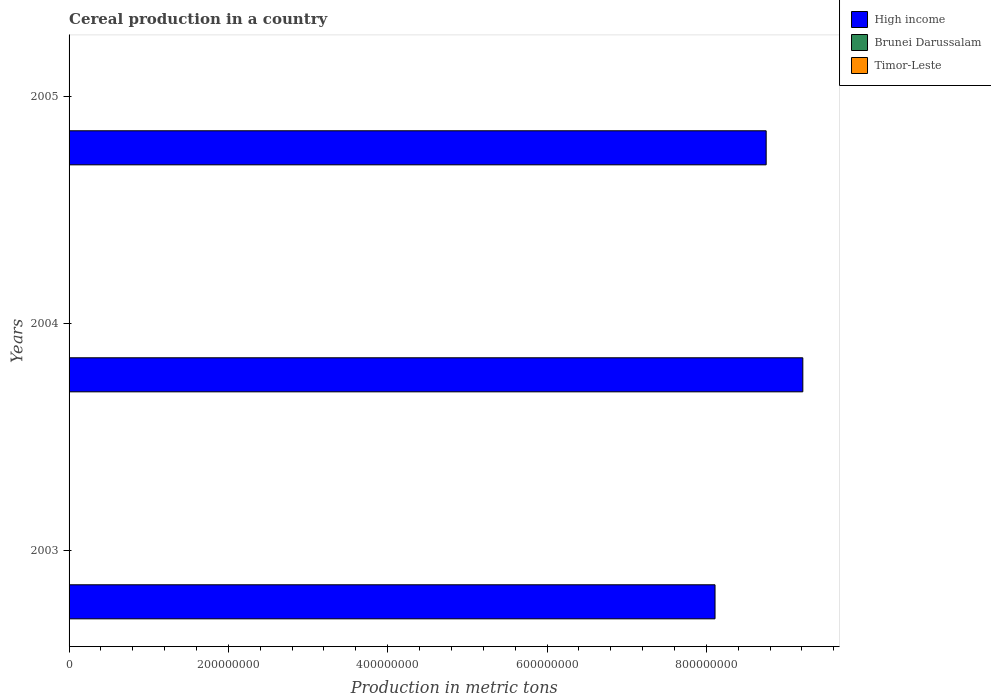How many groups of bars are there?
Ensure brevity in your answer.  3. Are the number of bars per tick equal to the number of legend labels?
Keep it short and to the point. Yes. What is the label of the 3rd group of bars from the top?
Provide a short and direct response. 2003. In how many cases, is the number of bars for a given year not equal to the number of legend labels?
Your answer should be compact. 0. What is the total cereal production in Timor-Leste in 2005?
Your response must be concise. 1.51e+05. Across all years, what is the maximum total cereal production in Brunei Darussalam?
Your response must be concise. 851. Across all years, what is the minimum total cereal production in Brunei Darussalam?
Offer a very short reply. 547. In which year was the total cereal production in Brunei Darussalam minimum?
Your answer should be very brief. 2003. What is the total total cereal production in Brunei Darussalam in the graph?
Make the answer very short. 2018. What is the difference between the total cereal production in Brunei Darussalam in 2003 and that in 2004?
Ensure brevity in your answer.  -73. What is the difference between the total cereal production in Timor-Leste in 2004 and the total cereal production in Brunei Darussalam in 2003?
Give a very brief answer. 1.17e+05. What is the average total cereal production in Brunei Darussalam per year?
Offer a very short reply. 672.67. In the year 2005, what is the difference between the total cereal production in High income and total cereal production in Timor-Leste?
Ensure brevity in your answer.  8.75e+08. In how many years, is the total cereal production in High income greater than 760000000 metric tons?
Your answer should be compact. 3. What is the ratio of the total cereal production in Brunei Darussalam in 2003 to that in 2005?
Provide a succinct answer. 0.64. Is the difference between the total cereal production in High income in 2003 and 2004 greater than the difference between the total cereal production in Timor-Leste in 2003 and 2004?
Offer a very short reply. No. What is the difference between the highest and the second highest total cereal production in High income?
Offer a terse response. 4.60e+07. What is the difference between the highest and the lowest total cereal production in High income?
Offer a terse response. 1.10e+08. In how many years, is the total cereal production in High income greater than the average total cereal production in High income taken over all years?
Provide a succinct answer. 2. What does the 1st bar from the top in 2005 represents?
Keep it short and to the point. Timor-Leste. What does the 2nd bar from the bottom in 2005 represents?
Your response must be concise. Brunei Darussalam. Is it the case that in every year, the sum of the total cereal production in Timor-Leste and total cereal production in High income is greater than the total cereal production in Brunei Darussalam?
Provide a succinct answer. Yes. How many years are there in the graph?
Provide a short and direct response. 3. Are the values on the major ticks of X-axis written in scientific E-notation?
Make the answer very short. No. Does the graph contain any zero values?
Your answer should be very brief. No. Does the graph contain grids?
Make the answer very short. No. How many legend labels are there?
Give a very brief answer. 3. What is the title of the graph?
Your answer should be compact. Cereal production in a country. What is the label or title of the X-axis?
Provide a short and direct response. Production in metric tons. What is the Production in metric tons in High income in 2003?
Offer a terse response. 8.11e+08. What is the Production in metric tons in Brunei Darussalam in 2003?
Provide a short and direct response. 547. What is the Production in metric tons of Timor-Leste in 2003?
Keep it short and to the point. 1.36e+05. What is the Production in metric tons of High income in 2004?
Offer a terse response. 9.21e+08. What is the Production in metric tons in Brunei Darussalam in 2004?
Provide a short and direct response. 620. What is the Production in metric tons in Timor-Leste in 2004?
Provide a succinct answer. 1.17e+05. What is the Production in metric tons of High income in 2005?
Keep it short and to the point. 8.75e+08. What is the Production in metric tons in Brunei Darussalam in 2005?
Make the answer very short. 851. What is the Production in metric tons in Timor-Leste in 2005?
Provide a short and direct response. 1.51e+05. Across all years, what is the maximum Production in metric tons in High income?
Your response must be concise. 9.21e+08. Across all years, what is the maximum Production in metric tons in Brunei Darussalam?
Offer a very short reply. 851. Across all years, what is the maximum Production in metric tons in Timor-Leste?
Provide a short and direct response. 1.51e+05. Across all years, what is the minimum Production in metric tons of High income?
Give a very brief answer. 8.11e+08. Across all years, what is the minimum Production in metric tons in Brunei Darussalam?
Your response must be concise. 547. Across all years, what is the minimum Production in metric tons in Timor-Leste?
Ensure brevity in your answer.  1.17e+05. What is the total Production in metric tons of High income in the graph?
Make the answer very short. 2.61e+09. What is the total Production in metric tons in Brunei Darussalam in the graph?
Offer a very short reply. 2018. What is the total Production in metric tons of Timor-Leste in the graph?
Your response must be concise. 4.04e+05. What is the difference between the Production in metric tons in High income in 2003 and that in 2004?
Keep it short and to the point. -1.10e+08. What is the difference between the Production in metric tons in Brunei Darussalam in 2003 and that in 2004?
Keep it short and to the point. -73. What is the difference between the Production in metric tons in Timor-Leste in 2003 and that in 2004?
Give a very brief answer. 1.84e+04. What is the difference between the Production in metric tons in High income in 2003 and that in 2005?
Your response must be concise. -6.42e+07. What is the difference between the Production in metric tons in Brunei Darussalam in 2003 and that in 2005?
Your answer should be compact. -304. What is the difference between the Production in metric tons in Timor-Leste in 2003 and that in 2005?
Keep it short and to the point. -1.55e+04. What is the difference between the Production in metric tons of High income in 2004 and that in 2005?
Your response must be concise. 4.60e+07. What is the difference between the Production in metric tons in Brunei Darussalam in 2004 and that in 2005?
Provide a succinct answer. -231. What is the difference between the Production in metric tons of Timor-Leste in 2004 and that in 2005?
Your answer should be compact. -3.39e+04. What is the difference between the Production in metric tons of High income in 2003 and the Production in metric tons of Brunei Darussalam in 2004?
Your answer should be very brief. 8.11e+08. What is the difference between the Production in metric tons of High income in 2003 and the Production in metric tons of Timor-Leste in 2004?
Make the answer very short. 8.11e+08. What is the difference between the Production in metric tons in Brunei Darussalam in 2003 and the Production in metric tons in Timor-Leste in 2004?
Your answer should be very brief. -1.17e+05. What is the difference between the Production in metric tons in High income in 2003 and the Production in metric tons in Brunei Darussalam in 2005?
Give a very brief answer. 8.11e+08. What is the difference between the Production in metric tons of High income in 2003 and the Production in metric tons of Timor-Leste in 2005?
Ensure brevity in your answer.  8.11e+08. What is the difference between the Production in metric tons in Brunei Darussalam in 2003 and the Production in metric tons in Timor-Leste in 2005?
Provide a succinct answer. -1.51e+05. What is the difference between the Production in metric tons of High income in 2004 and the Production in metric tons of Brunei Darussalam in 2005?
Your answer should be very brief. 9.21e+08. What is the difference between the Production in metric tons in High income in 2004 and the Production in metric tons in Timor-Leste in 2005?
Offer a terse response. 9.21e+08. What is the difference between the Production in metric tons in Brunei Darussalam in 2004 and the Production in metric tons in Timor-Leste in 2005?
Make the answer very short. -1.50e+05. What is the average Production in metric tons of High income per year?
Provide a succinct answer. 8.69e+08. What is the average Production in metric tons in Brunei Darussalam per year?
Make the answer very short. 672.67. What is the average Production in metric tons in Timor-Leste per year?
Offer a very short reply. 1.35e+05. In the year 2003, what is the difference between the Production in metric tons of High income and Production in metric tons of Brunei Darussalam?
Your answer should be very brief. 8.11e+08. In the year 2003, what is the difference between the Production in metric tons in High income and Production in metric tons in Timor-Leste?
Ensure brevity in your answer.  8.11e+08. In the year 2003, what is the difference between the Production in metric tons of Brunei Darussalam and Production in metric tons of Timor-Leste?
Offer a terse response. -1.35e+05. In the year 2004, what is the difference between the Production in metric tons of High income and Production in metric tons of Brunei Darussalam?
Your answer should be compact. 9.21e+08. In the year 2004, what is the difference between the Production in metric tons of High income and Production in metric tons of Timor-Leste?
Give a very brief answer. 9.21e+08. In the year 2004, what is the difference between the Production in metric tons in Brunei Darussalam and Production in metric tons in Timor-Leste?
Ensure brevity in your answer.  -1.17e+05. In the year 2005, what is the difference between the Production in metric tons of High income and Production in metric tons of Brunei Darussalam?
Make the answer very short. 8.75e+08. In the year 2005, what is the difference between the Production in metric tons in High income and Production in metric tons in Timor-Leste?
Your response must be concise. 8.75e+08. In the year 2005, what is the difference between the Production in metric tons in Brunei Darussalam and Production in metric tons in Timor-Leste?
Keep it short and to the point. -1.50e+05. What is the ratio of the Production in metric tons of High income in 2003 to that in 2004?
Provide a succinct answer. 0.88. What is the ratio of the Production in metric tons of Brunei Darussalam in 2003 to that in 2004?
Offer a terse response. 0.88. What is the ratio of the Production in metric tons of Timor-Leste in 2003 to that in 2004?
Provide a short and direct response. 1.16. What is the ratio of the Production in metric tons of High income in 2003 to that in 2005?
Give a very brief answer. 0.93. What is the ratio of the Production in metric tons in Brunei Darussalam in 2003 to that in 2005?
Keep it short and to the point. 0.64. What is the ratio of the Production in metric tons in Timor-Leste in 2003 to that in 2005?
Give a very brief answer. 0.9. What is the ratio of the Production in metric tons in High income in 2004 to that in 2005?
Ensure brevity in your answer.  1.05. What is the ratio of the Production in metric tons of Brunei Darussalam in 2004 to that in 2005?
Ensure brevity in your answer.  0.73. What is the ratio of the Production in metric tons in Timor-Leste in 2004 to that in 2005?
Your answer should be compact. 0.78. What is the difference between the highest and the second highest Production in metric tons of High income?
Ensure brevity in your answer.  4.60e+07. What is the difference between the highest and the second highest Production in metric tons in Brunei Darussalam?
Offer a terse response. 231. What is the difference between the highest and the second highest Production in metric tons of Timor-Leste?
Ensure brevity in your answer.  1.55e+04. What is the difference between the highest and the lowest Production in metric tons in High income?
Provide a succinct answer. 1.10e+08. What is the difference between the highest and the lowest Production in metric tons of Brunei Darussalam?
Provide a short and direct response. 304. What is the difference between the highest and the lowest Production in metric tons in Timor-Leste?
Your response must be concise. 3.39e+04. 